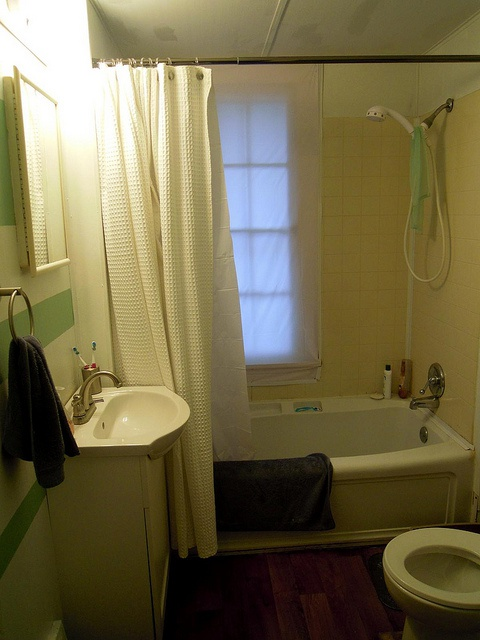Describe the objects in this image and their specific colors. I can see toilet in white, black, and olive tones, sink in white and tan tones, cup in white, olive, and black tones, bottle in maroon, black, olive, and white tones, and bottle in white, olive, and black tones in this image. 